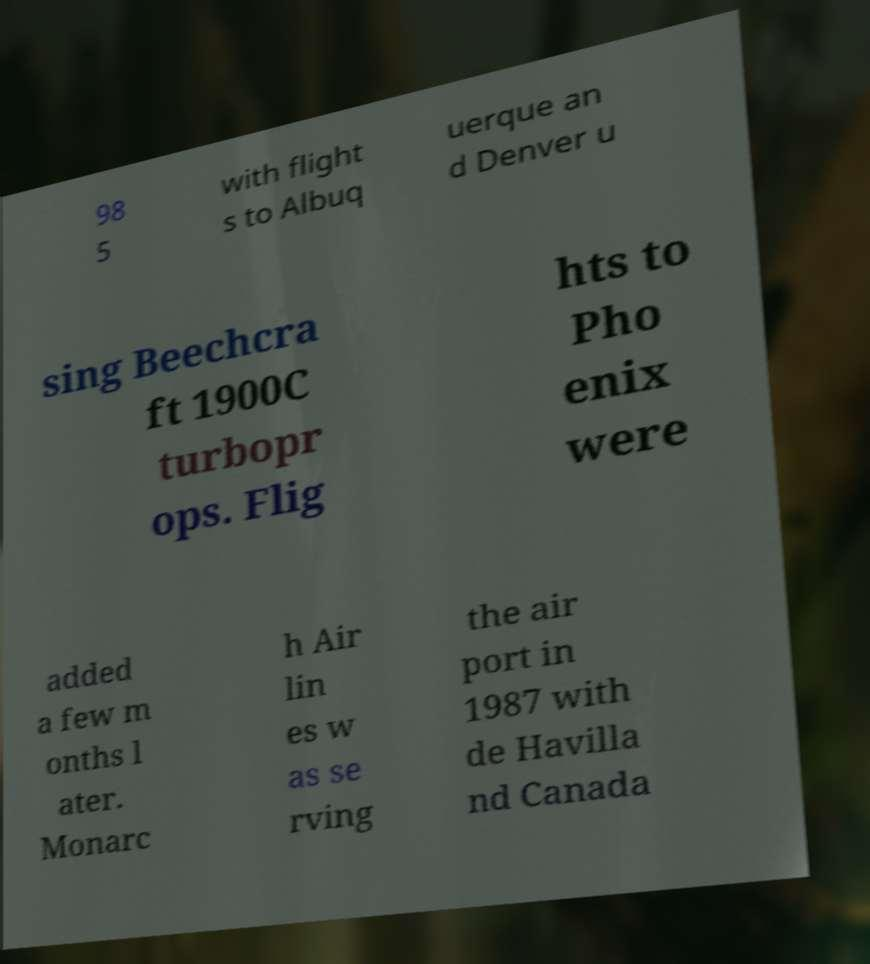I need the written content from this picture converted into text. Can you do that? 98 5 with flight s to Albuq uerque an d Denver u sing Beechcra ft 1900C turbopr ops. Flig hts to Pho enix were added a few m onths l ater. Monarc h Air lin es w as se rving the air port in 1987 with de Havilla nd Canada 